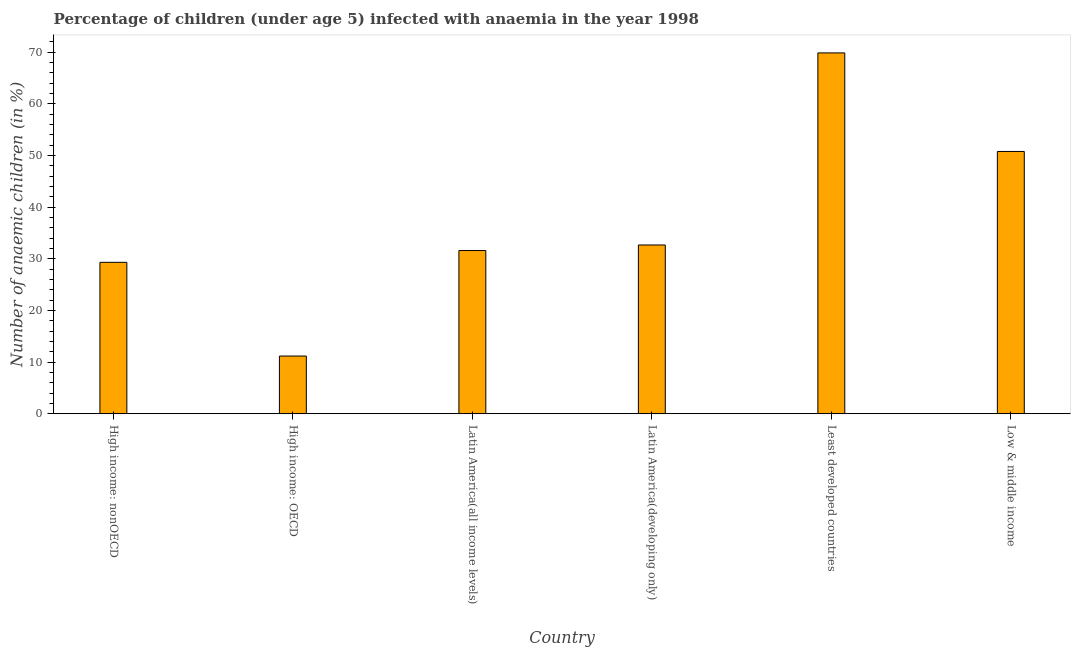Does the graph contain any zero values?
Provide a short and direct response. No. What is the title of the graph?
Provide a short and direct response. Percentage of children (under age 5) infected with anaemia in the year 1998. What is the label or title of the X-axis?
Offer a very short reply. Country. What is the label or title of the Y-axis?
Provide a succinct answer. Number of anaemic children (in %). What is the number of anaemic children in Latin America(all income levels)?
Your answer should be very brief. 31.58. Across all countries, what is the maximum number of anaemic children?
Keep it short and to the point. 69.83. Across all countries, what is the minimum number of anaemic children?
Your response must be concise. 11.17. In which country was the number of anaemic children maximum?
Your response must be concise. Least developed countries. In which country was the number of anaemic children minimum?
Your response must be concise. High income: OECD. What is the sum of the number of anaemic children?
Offer a terse response. 225.3. What is the difference between the number of anaemic children in High income: nonOECD and Low & middle income?
Provide a short and direct response. -21.46. What is the average number of anaemic children per country?
Ensure brevity in your answer.  37.55. What is the median number of anaemic children?
Give a very brief answer. 32.12. In how many countries, is the number of anaemic children greater than 40 %?
Your response must be concise. 2. Is the number of anaemic children in Latin America(all income levels) less than that in Latin America(developing only)?
Your response must be concise. Yes. What is the difference between the highest and the second highest number of anaemic children?
Ensure brevity in your answer.  19.07. Is the sum of the number of anaemic children in Latin America(developing only) and Least developed countries greater than the maximum number of anaemic children across all countries?
Make the answer very short. Yes. What is the difference between the highest and the lowest number of anaemic children?
Offer a very short reply. 58.66. How many bars are there?
Your response must be concise. 6. What is the difference between two consecutive major ticks on the Y-axis?
Give a very brief answer. 10. What is the Number of anaemic children (in %) of High income: nonOECD?
Make the answer very short. 29.3. What is the Number of anaemic children (in %) of High income: OECD?
Give a very brief answer. 11.17. What is the Number of anaemic children (in %) in Latin America(all income levels)?
Give a very brief answer. 31.58. What is the Number of anaemic children (in %) of Latin America(developing only)?
Your answer should be very brief. 32.66. What is the Number of anaemic children (in %) in Least developed countries?
Keep it short and to the point. 69.83. What is the Number of anaemic children (in %) in Low & middle income?
Ensure brevity in your answer.  50.76. What is the difference between the Number of anaemic children (in %) in High income: nonOECD and High income: OECD?
Offer a very short reply. 18.13. What is the difference between the Number of anaemic children (in %) in High income: nonOECD and Latin America(all income levels)?
Ensure brevity in your answer.  -2.28. What is the difference between the Number of anaemic children (in %) in High income: nonOECD and Latin America(developing only)?
Your answer should be very brief. -3.36. What is the difference between the Number of anaemic children (in %) in High income: nonOECD and Least developed countries?
Give a very brief answer. -40.53. What is the difference between the Number of anaemic children (in %) in High income: nonOECD and Low & middle income?
Give a very brief answer. -21.46. What is the difference between the Number of anaemic children (in %) in High income: OECD and Latin America(all income levels)?
Your response must be concise. -20.42. What is the difference between the Number of anaemic children (in %) in High income: OECD and Latin America(developing only)?
Provide a short and direct response. -21.49. What is the difference between the Number of anaemic children (in %) in High income: OECD and Least developed countries?
Offer a very short reply. -58.66. What is the difference between the Number of anaemic children (in %) in High income: OECD and Low & middle income?
Keep it short and to the point. -39.59. What is the difference between the Number of anaemic children (in %) in Latin America(all income levels) and Latin America(developing only)?
Give a very brief answer. -1.08. What is the difference between the Number of anaemic children (in %) in Latin America(all income levels) and Least developed countries?
Provide a short and direct response. -38.25. What is the difference between the Number of anaemic children (in %) in Latin America(all income levels) and Low & middle income?
Provide a succinct answer. -19.18. What is the difference between the Number of anaemic children (in %) in Latin America(developing only) and Least developed countries?
Your answer should be very brief. -37.17. What is the difference between the Number of anaemic children (in %) in Latin America(developing only) and Low & middle income?
Offer a terse response. -18.1. What is the difference between the Number of anaemic children (in %) in Least developed countries and Low & middle income?
Give a very brief answer. 19.07. What is the ratio of the Number of anaemic children (in %) in High income: nonOECD to that in High income: OECD?
Keep it short and to the point. 2.62. What is the ratio of the Number of anaemic children (in %) in High income: nonOECD to that in Latin America(all income levels)?
Offer a very short reply. 0.93. What is the ratio of the Number of anaemic children (in %) in High income: nonOECD to that in Latin America(developing only)?
Your answer should be compact. 0.9. What is the ratio of the Number of anaemic children (in %) in High income: nonOECD to that in Least developed countries?
Provide a short and direct response. 0.42. What is the ratio of the Number of anaemic children (in %) in High income: nonOECD to that in Low & middle income?
Give a very brief answer. 0.58. What is the ratio of the Number of anaemic children (in %) in High income: OECD to that in Latin America(all income levels)?
Give a very brief answer. 0.35. What is the ratio of the Number of anaemic children (in %) in High income: OECD to that in Latin America(developing only)?
Make the answer very short. 0.34. What is the ratio of the Number of anaemic children (in %) in High income: OECD to that in Least developed countries?
Make the answer very short. 0.16. What is the ratio of the Number of anaemic children (in %) in High income: OECD to that in Low & middle income?
Your answer should be very brief. 0.22. What is the ratio of the Number of anaemic children (in %) in Latin America(all income levels) to that in Least developed countries?
Your response must be concise. 0.45. What is the ratio of the Number of anaemic children (in %) in Latin America(all income levels) to that in Low & middle income?
Offer a very short reply. 0.62. What is the ratio of the Number of anaemic children (in %) in Latin America(developing only) to that in Least developed countries?
Your answer should be very brief. 0.47. What is the ratio of the Number of anaemic children (in %) in Latin America(developing only) to that in Low & middle income?
Give a very brief answer. 0.64. What is the ratio of the Number of anaemic children (in %) in Least developed countries to that in Low & middle income?
Your response must be concise. 1.38. 